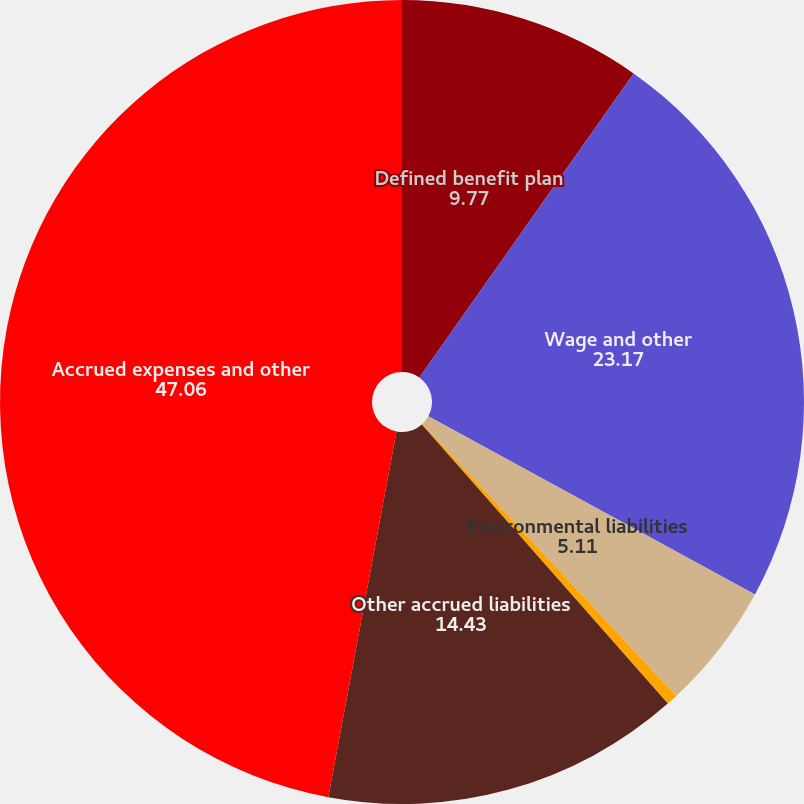<chart> <loc_0><loc_0><loc_500><loc_500><pie_chart><fcel>Defined benefit plan<fcel>Wage and other<fcel>Environmental liabilities<fcel>Asset retirement obligations<fcel>Other accrued liabilities<fcel>Accrued expenses and other<nl><fcel>9.77%<fcel>23.17%<fcel>5.11%<fcel>0.45%<fcel>14.43%<fcel>47.06%<nl></chart> 